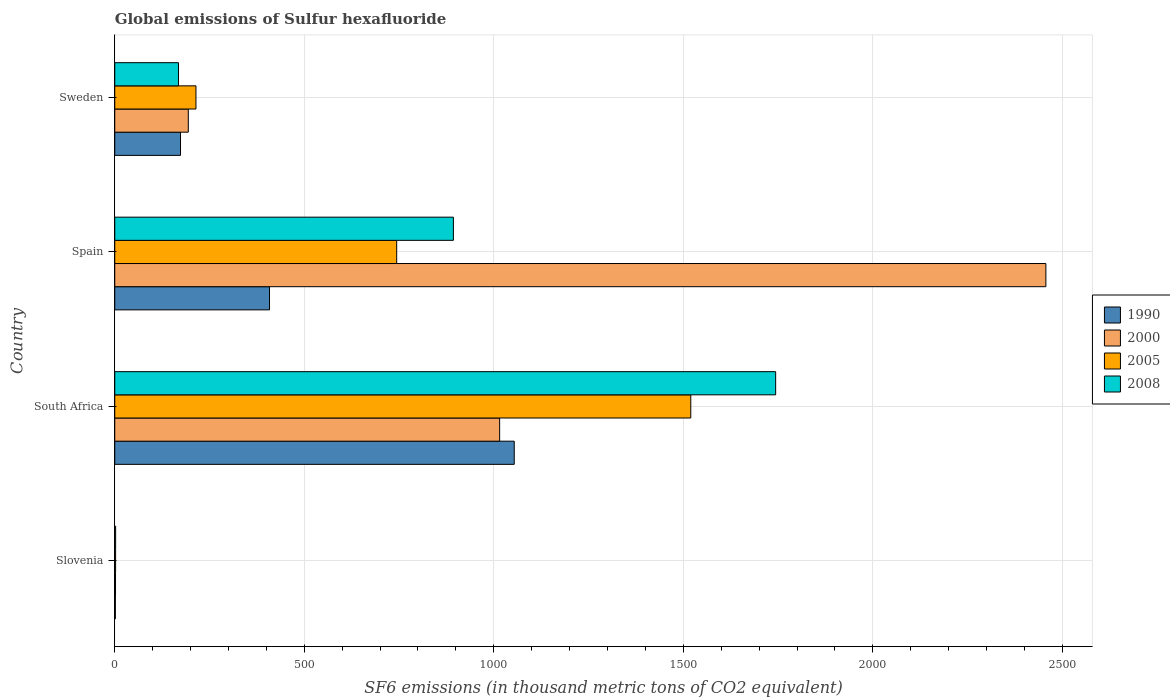How many groups of bars are there?
Offer a very short reply. 4. Are the number of bars per tick equal to the number of legend labels?
Ensure brevity in your answer.  Yes. Are the number of bars on each tick of the Y-axis equal?
Provide a succinct answer. Yes. How many bars are there on the 2nd tick from the top?
Keep it short and to the point. 4. What is the label of the 4th group of bars from the top?
Keep it short and to the point. Slovenia. Across all countries, what is the maximum global emissions of Sulfur hexafluoride in 2008?
Make the answer very short. 1743.6. Across all countries, what is the minimum global emissions of Sulfur hexafluoride in 2005?
Your answer should be compact. 2.2. In which country was the global emissions of Sulfur hexafluoride in 2000 maximum?
Your answer should be compact. Spain. In which country was the global emissions of Sulfur hexafluoride in 2008 minimum?
Provide a short and direct response. Slovenia. What is the total global emissions of Sulfur hexafluoride in 2005 in the graph?
Give a very brief answer. 2479.9. What is the difference between the global emissions of Sulfur hexafluoride in 2008 in South Africa and that in Spain?
Offer a very short reply. 850.2. What is the difference between the global emissions of Sulfur hexafluoride in 1990 in Slovenia and the global emissions of Sulfur hexafluoride in 2000 in Spain?
Your answer should be very brief. -2454.9. What is the average global emissions of Sulfur hexafluoride in 2005 per country?
Keep it short and to the point. 619.97. What is the difference between the global emissions of Sulfur hexafluoride in 2005 and global emissions of Sulfur hexafluoride in 2008 in South Africa?
Provide a short and direct response. -223.9. In how many countries, is the global emissions of Sulfur hexafluoride in 2008 greater than 500 thousand metric tons?
Your response must be concise. 2. What is the ratio of the global emissions of Sulfur hexafluoride in 2005 in South Africa to that in Sweden?
Keep it short and to the point. 7.09. What is the difference between the highest and the second highest global emissions of Sulfur hexafluoride in 2005?
Provide a succinct answer. 775.9. What is the difference between the highest and the lowest global emissions of Sulfur hexafluoride in 1990?
Make the answer very short. 1052.3. In how many countries, is the global emissions of Sulfur hexafluoride in 2000 greater than the average global emissions of Sulfur hexafluoride in 2000 taken over all countries?
Offer a very short reply. 2. Is the sum of the global emissions of Sulfur hexafluoride in 2005 in South Africa and Spain greater than the maximum global emissions of Sulfur hexafluoride in 2008 across all countries?
Keep it short and to the point. Yes. Is it the case that in every country, the sum of the global emissions of Sulfur hexafluoride in 2005 and global emissions of Sulfur hexafluoride in 2008 is greater than the sum of global emissions of Sulfur hexafluoride in 2000 and global emissions of Sulfur hexafluoride in 1990?
Give a very brief answer. No. What does the 1st bar from the top in South Africa represents?
Your answer should be compact. 2008. What does the 3rd bar from the bottom in Slovenia represents?
Provide a short and direct response. 2005. Are all the bars in the graph horizontal?
Provide a short and direct response. Yes. How many countries are there in the graph?
Offer a terse response. 4. Are the values on the major ticks of X-axis written in scientific E-notation?
Offer a very short reply. No. Does the graph contain any zero values?
Your answer should be very brief. No. How many legend labels are there?
Provide a succinct answer. 4. How are the legend labels stacked?
Ensure brevity in your answer.  Vertical. What is the title of the graph?
Offer a terse response. Global emissions of Sulfur hexafluoride. Does "2007" appear as one of the legend labels in the graph?
Your answer should be compact. No. What is the label or title of the X-axis?
Your response must be concise. SF6 emissions (in thousand metric tons of CO2 equivalent). What is the SF6 emissions (in thousand metric tons of CO2 equivalent) in 2008 in Slovenia?
Offer a terse response. 2.3. What is the SF6 emissions (in thousand metric tons of CO2 equivalent) in 1990 in South Africa?
Offer a very short reply. 1053.9. What is the SF6 emissions (in thousand metric tons of CO2 equivalent) of 2000 in South Africa?
Provide a short and direct response. 1015.4. What is the SF6 emissions (in thousand metric tons of CO2 equivalent) in 2005 in South Africa?
Ensure brevity in your answer.  1519.7. What is the SF6 emissions (in thousand metric tons of CO2 equivalent) of 2008 in South Africa?
Your answer should be compact. 1743.6. What is the SF6 emissions (in thousand metric tons of CO2 equivalent) of 1990 in Spain?
Your answer should be very brief. 408.3. What is the SF6 emissions (in thousand metric tons of CO2 equivalent) of 2000 in Spain?
Make the answer very short. 2456.5. What is the SF6 emissions (in thousand metric tons of CO2 equivalent) of 2005 in Spain?
Keep it short and to the point. 743.8. What is the SF6 emissions (in thousand metric tons of CO2 equivalent) of 2008 in Spain?
Provide a short and direct response. 893.4. What is the SF6 emissions (in thousand metric tons of CO2 equivalent) of 1990 in Sweden?
Ensure brevity in your answer.  173.5. What is the SF6 emissions (in thousand metric tons of CO2 equivalent) of 2000 in Sweden?
Give a very brief answer. 194. What is the SF6 emissions (in thousand metric tons of CO2 equivalent) in 2005 in Sweden?
Provide a short and direct response. 214.2. What is the SF6 emissions (in thousand metric tons of CO2 equivalent) of 2008 in Sweden?
Your answer should be compact. 168.1. Across all countries, what is the maximum SF6 emissions (in thousand metric tons of CO2 equivalent) of 1990?
Your answer should be very brief. 1053.9. Across all countries, what is the maximum SF6 emissions (in thousand metric tons of CO2 equivalent) of 2000?
Ensure brevity in your answer.  2456.5. Across all countries, what is the maximum SF6 emissions (in thousand metric tons of CO2 equivalent) of 2005?
Your answer should be very brief. 1519.7. Across all countries, what is the maximum SF6 emissions (in thousand metric tons of CO2 equivalent) in 2008?
Your answer should be compact. 1743.6. Across all countries, what is the minimum SF6 emissions (in thousand metric tons of CO2 equivalent) in 2008?
Keep it short and to the point. 2.3. What is the total SF6 emissions (in thousand metric tons of CO2 equivalent) in 1990 in the graph?
Your response must be concise. 1637.3. What is the total SF6 emissions (in thousand metric tons of CO2 equivalent) in 2000 in the graph?
Give a very brief answer. 3667.9. What is the total SF6 emissions (in thousand metric tons of CO2 equivalent) of 2005 in the graph?
Offer a terse response. 2479.9. What is the total SF6 emissions (in thousand metric tons of CO2 equivalent) of 2008 in the graph?
Keep it short and to the point. 2807.4. What is the difference between the SF6 emissions (in thousand metric tons of CO2 equivalent) in 1990 in Slovenia and that in South Africa?
Your response must be concise. -1052.3. What is the difference between the SF6 emissions (in thousand metric tons of CO2 equivalent) in 2000 in Slovenia and that in South Africa?
Keep it short and to the point. -1013.4. What is the difference between the SF6 emissions (in thousand metric tons of CO2 equivalent) of 2005 in Slovenia and that in South Africa?
Offer a terse response. -1517.5. What is the difference between the SF6 emissions (in thousand metric tons of CO2 equivalent) in 2008 in Slovenia and that in South Africa?
Offer a very short reply. -1741.3. What is the difference between the SF6 emissions (in thousand metric tons of CO2 equivalent) in 1990 in Slovenia and that in Spain?
Your answer should be very brief. -406.7. What is the difference between the SF6 emissions (in thousand metric tons of CO2 equivalent) in 2000 in Slovenia and that in Spain?
Provide a short and direct response. -2454.5. What is the difference between the SF6 emissions (in thousand metric tons of CO2 equivalent) in 2005 in Slovenia and that in Spain?
Offer a terse response. -741.6. What is the difference between the SF6 emissions (in thousand metric tons of CO2 equivalent) of 2008 in Slovenia and that in Spain?
Offer a terse response. -891.1. What is the difference between the SF6 emissions (in thousand metric tons of CO2 equivalent) of 1990 in Slovenia and that in Sweden?
Your answer should be compact. -171.9. What is the difference between the SF6 emissions (in thousand metric tons of CO2 equivalent) in 2000 in Slovenia and that in Sweden?
Make the answer very short. -192. What is the difference between the SF6 emissions (in thousand metric tons of CO2 equivalent) of 2005 in Slovenia and that in Sweden?
Ensure brevity in your answer.  -212. What is the difference between the SF6 emissions (in thousand metric tons of CO2 equivalent) of 2008 in Slovenia and that in Sweden?
Offer a very short reply. -165.8. What is the difference between the SF6 emissions (in thousand metric tons of CO2 equivalent) of 1990 in South Africa and that in Spain?
Your answer should be compact. 645.6. What is the difference between the SF6 emissions (in thousand metric tons of CO2 equivalent) of 2000 in South Africa and that in Spain?
Provide a succinct answer. -1441.1. What is the difference between the SF6 emissions (in thousand metric tons of CO2 equivalent) in 2005 in South Africa and that in Spain?
Your answer should be very brief. 775.9. What is the difference between the SF6 emissions (in thousand metric tons of CO2 equivalent) in 2008 in South Africa and that in Spain?
Offer a terse response. 850.2. What is the difference between the SF6 emissions (in thousand metric tons of CO2 equivalent) of 1990 in South Africa and that in Sweden?
Your answer should be very brief. 880.4. What is the difference between the SF6 emissions (in thousand metric tons of CO2 equivalent) of 2000 in South Africa and that in Sweden?
Offer a terse response. 821.4. What is the difference between the SF6 emissions (in thousand metric tons of CO2 equivalent) in 2005 in South Africa and that in Sweden?
Offer a terse response. 1305.5. What is the difference between the SF6 emissions (in thousand metric tons of CO2 equivalent) in 2008 in South Africa and that in Sweden?
Keep it short and to the point. 1575.5. What is the difference between the SF6 emissions (in thousand metric tons of CO2 equivalent) of 1990 in Spain and that in Sweden?
Offer a terse response. 234.8. What is the difference between the SF6 emissions (in thousand metric tons of CO2 equivalent) in 2000 in Spain and that in Sweden?
Provide a short and direct response. 2262.5. What is the difference between the SF6 emissions (in thousand metric tons of CO2 equivalent) of 2005 in Spain and that in Sweden?
Provide a short and direct response. 529.6. What is the difference between the SF6 emissions (in thousand metric tons of CO2 equivalent) of 2008 in Spain and that in Sweden?
Offer a very short reply. 725.3. What is the difference between the SF6 emissions (in thousand metric tons of CO2 equivalent) in 1990 in Slovenia and the SF6 emissions (in thousand metric tons of CO2 equivalent) in 2000 in South Africa?
Offer a terse response. -1013.8. What is the difference between the SF6 emissions (in thousand metric tons of CO2 equivalent) of 1990 in Slovenia and the SF6 emissions (in thousand metric tons of CO2 equivalent) of 2005 in South Africa?
Make the answer very short. -1518.1. What is the difference between the SF6 emissions (in thousand metric tons of CO2 equivalent) in 1990 in Slovenia and the SF6 emissions (in thousand metric tons of CO2 equivalent) in 2008 in South Africa?
Your answer should be compact. -1742. What is the difference between the SF6 emissions (in thousand metric tons of CO2 equivalent) of 2000 in Slovenia and the SF6 emissions (in thousand metric tons of CO2 equivalent) of 2005 in South Africa?
Offer a terse response. -1517.7. What is the difference between the SF6 emissions (in thousand metric tons of CO2 equivalent) of 2000 in Slovenia and the SF6 emissions (in thousand metric tons of CO2 equivalent) of 2008 in South Africa?
Provide a short and direct response. -1741.6. What is the difference between the SF6 emissions (in thousand metric tons of CO2 equivalent) in 2005 in Slovenia and the SF6 emissions (in thousand metric tons of CO2 equivalent) in 2008 in South Africa?
Your answer should be compact. -1741.4. What is the difference between the SF6 emissions (in thousand metric tons of CO2 equivalent) in 1990 in Slovenia and the SF6 emissions (in thousand metric tons of CO2 equivalent) in 2000 in Spain?
Offer a terse response. -2454.9. What is the difference between the SF6 emissions (in thousand metric tons of CO2 equivalent) in 1990 in Slovenia and the SF6 emissions (in thousand metric tons of CO2 equivalent) in 2005 in Spain?
Offer a terse response. -742.2. What is the difference between the SF6 emissions (in thousand metric tons of CO2 equivalent) in 1990 in Slovenia and the SF6 emissions (in thousand metric tons of CO2 equivalent) in 2008 in Spain?
Make the answer very short. -891.8. What is the difference between the SF6 emissions (in thousand metric tons of CO2 equivalent) of 2000 in Slovenia and the SF6 emissions (in thousand metric tons of CO2 equivalent) of 2005 in Spain?
Offer a terse response. -741.8. What is the difference between the SF6 emissions (in thousand metric tons of CO2 equivalent) in 2000 in Slovenia and the SF6 emissions (in thousand metric tons of CO2 equivalent) in 2008 in Spain?
Your answer should be compact. -891.4. What is the difference between the SF6 emissions (in thousand metric tons of CO2 equivalent) of 2005 in Slovenia and the SF6 emissions (in thousand metric tons of CO2 equivalent) of 2008 in Spain?
Your answer should be compact. -891.2. What is the difference between the SF6 emissions (in thousand metric tons of CO2 equivalent) in 1990 in Slovenia and the SF6 emissions (in thousand metric tons of CO2 equivalent) in 2000 in Sweden?
Your answer should be very brief. -192.4. What is the difference between the SF6 emissions (in thousand metric tons of CO2 equivalent) of 1990 in Slovenia and the SF6 emissions (in thousand metric tons of CO2 equivalent) of 2005 in Sweden?
Give a very brief answer. -212.6. What is the difference between the SF6 emissions (in thousand metric tons of CO2 equivalent) in 1990 in Slovenia and the SF6 emissions (in thousand metric tons of CO2 equivalent) in 2008 in Sweden?
Provide a succinct answer. -166.5. What is the difference between the SF6 emissions (in thousand metric tons of CO2 equivalent) of 2000 in Slovenia and the SF6 emissions (in thousand metric tons of CO2 equivalent) of 2005 in Sweden?
Your answer should be very brief. -212.2. What is the difference between the SF6 emissions (in thousand metric tons of CO2 equivalent) of 2000 in Slovenia and the SF6 emissions (in thousand metric tons of CO2 equivalent) of 2008 in Sweden?
Keep it short and to the point. -166.1. What is the difference between the SF6 emissions (in thousand metric tons of CO2 equivalent) in 2005 in Slovenia and the SF6 emissions (in thousand metric tons of CO2 equivalent) in 2008 in Sweden?
Your answer should be very brief. -165.9. What is the difference between the SF6 emissions (in thousand metric tons of CO2 equivalent) of 1990 in South Africa and the SF6 emissions (in thousand metric tons of CO2 equivalent) of 2000 in Spain?
Provide a succinct answer. -1402.6. What is the difference between the SF6 emissions (in thousand metric tons of CO2 equivalent) in 1990 in South Africa and the SF6 emissions (in thousand metric tons of CO2 equivalent) in 2005 in Spain?
Provide a succinct answer. 310.1. What is the difference between the SF6 emissions (in thousand metric tons of CO2 equivalent) in 1990 in South Africa and the SF6 emissions (in thousand metric tons of CO2 equivalent) in 2008 in Spain?
Provide a succinct answer. 160.5. What is the difference between the SF6 emissions (in thousand metric tons of CO2 equivalent) of 2000 in South Africa and the SF6 emissions (in thousand metric tons of CO2 equivalent) of 2005 in Spain?
Give a very brief answer. 271.6. What is the difference between the SF6 emissions (in thousand metric tons of CO2 equivalent) in 2000 in South Africa and the SF6 emissions (in thousand metric tons of CO2 equivalent) in 2008 in Spain?
Keep it short and to the point. 122. What is the difference between the SF6 emissions (in thousand metric tons of CO2 equivalent) in 2005 in South Africa and the SF6 emissions (in thousand metric tons of CO2 equivalent) in 2008 in Spain?
Provide a short and direct response. 626.3. What is the difference between the SF6 emissions (in thousand metric tons of CO2 equivalent) of 1990 in South Africa and the SF6 emissions (in thousand metric tons of CO2 equivalent) of 2000 in Sweden?
Keep it short and to the point. 859.9. What is the difference between the SF6 emissions (in thousand metric tons of CO2 equivalent) in 1990 in South Africa and the SF6 emissions (in thousand metric tons of CO2 equivalent) in 2005 in Sweden?
Give a very brief answer. 839.7. What is the difference between the SF6 emissions (in thousand metric tons of CO2 equivalent) of 1990 in South Africa and the SF6 emissions (in thousand metric tons of CO2 equivalent) of 2008 in Sweden?
Make the answer very short. 885.8. What is the difference between the SF6 emissions (in thousand metric tons of CO2 equivalent) in 2000 in South Africa and the SF6 emissions (in thousand metric tons of CO2 equivalent) in 2005 in Sweden?
Provide a short and direct response. 801.2. What is the difference between the SF6 emissions (in thousand metric tons of CO2 equivalent) of 2000 in South Africa and the SF6 emissions (in thousand metric tons of CO2 equivalent) of 2008 in Sweden?
Offer a very short reply. 847.3. What is the difference between the SF6 emissions (in thousand metric tons of CO2 equivalent) in 2005 in South Africa and the SF6 emissions (in thousand metric tons of CO2 equivalent) in 2008 in Sweden?
Your response must be concise. 1351.6. What is the difference between the SF6 emissions (in thousand metric tons of CO2 equivalent) in 1990 in Spain and the SF6 emissions (in thousand metric tons of CO2 equivalent) in 2000 in Sweden?
Provide a succinct answer. 214.3. What is the difference between the SF6 emissions (in thousand metric tons of CO2 equivalent) of 1990 in Spain and the SF6 emissions (in thousand metric tons of CO2 equivalent) of 2005 in Sweden?
Provide a short and direct response. 194.1. What is the difference between the SF6 emissions (in thousand metric tons of CO2 equivalent) in 1990 in Spain and the SF6 emissions (in thousand metric tons of CO2 equivalent) in 2008 in Sweden?
Provide a succinct answer. 240.2. What is the difference between the SF6 emissions (in thousand metric tons of CO2 equivalent) in 2000 in Spain and the SF6 emissions (in thousand metric tons of CO2 equivalent) in 2005 in Sweden?
Your response must be concise. 2242.3. What is the difference between the SF6 emissions (in thousand metric tons of CO2 equivalent) in 2000 in Spain and the SF6 emissions (in thousand metric tons of CO2 equivalent) in 2008 in Sweden?
Your response must be concise. 2288.4. What is the difference between the SF6 emissions (in thousand metric tons of CO2 equivalent) in 2005 in Spain and the SF6 emissions (in thousand metric tons of CO2 equivalent) in 2008 in Sweden?
Provide a short and direct response. 575.7. What is the average SF6 emissions (in thousand metric tons of CO2 equivalent) of 1990 per country?
Ensure brevity in your answer.  409.32. What is the average SF6 emissions (in thousand metric tons of CO2 equivalent) in 2000 per country?
Your answer should be very brief. 916.98. What is the average SF6 emissions (in thousand metric tons of CO2 equivalent) of 2005 per country?
Give a very brief answer. 619.98. What is the average SF6 emissions (in thousand metric tons of CO2 equivalent) in 2008 per country?
Your response must be concise. 701.85. What is the difference between the SF6 emissions (in thousand metric tons of CO2 equivalent) of 1990 and SF6 emissions (in thousand metric tons of CO2 equivalent) of 2000 in Slovenia?
Provide a short and direct response. -0.4. What is the difference between the SF6 emissions (in thousand metric tons of CO2 equivalent) of 1990 and SF6 emissions (in thousand metric tons of CO2 equivalent) of 2005 in Slovenia?
Your answer should be compact. -0.6. What is the difference between the SF6 emissions (in thousand metric tons of CO2 equivalent) of 2000 and SF6 emissions (in thousand metric tons of CO2 equivalent) of 2008 in Slovenia?
Ensure brevity in your answer.  -0.3. What is the difference between the SF6 emissions (in thousand metric tons of CO2 equivalent) of 1990 and SF6 emissions (in thousand metric tons of CO2 equivalent) of 2000 in South Africa?
Provide a short and direct response. 38.5. What is the difference between the SF6 emissions (in thousand metric tons of CO2 equivalent) in 1990 and SF6 emissions (in thousand metric tons of CO2 equivalent) in 2005 in South Africa?
Your answer should be compact. -465.8. What is the difference between the SF6 emissions (in thousand metric tons of CO2 equivalent) of 1990 and SF6 emissions (in thousand metric tons of CO2 equivalent) of 2008 in South Africa?
Your answer should be compact. -689.7. What is the difference between the SF6 emissions (in thousand metric tons of CO2 equivalent) in 2000 and SF6 emissions (in thousand metric tons of CO2 equivalent) in 2005 in South Africa?
Offer a terse response. -504.3. What is the difference between the SF6 emissions (in thousand metric tons of CO2 equivalent) of 2000 and SF6 emissions (in thousand metric tons of CO2 equivalent) of 2008 in South Africa?
Keep it short and to the point. -728.2. What is the difference between the SF6 emissions (in thousand metric tons of CO2 equivalent) in 2005 and SF6 emissions (in thousand metric tons of CO2 equivalent) in 2008 in South Africa?
Provide a short and direct response. -223.9. What is the difference between the SF6 emissions (in thousand metric tons of CO2 equivalent) of 1990 and SF6 emissions (in thousand metric tons of CO2 equivalent) of 2000 in Spain?
Give a very brief answer. -2048.2. What is the difference between the SF6 emissions (in thousand metric tons of CO2 equivalent) in 1990 and SF6 emissions (in thousand metric tons of CO2 equivalent) in 2005 in Spain?
Offer a very short reply. -335.5. What is the difference between the SF6 emissions (in thousand metric tons of CO2 equivalent) in 1990 and SF6 emissions (in thousand metric tons of CO2 equivalent) in 2008 in Spain?
Keep it short and to the point. -485.1. What is the difference between the SF6 emissions (in thousand metric tons of CO2 equivalent) in 2000 and SF6 emissions (in thousand metric tons of CO2 equivalent) in 2005 in Spain?
Offer a terse response. 1712.7. What is the difference between the SF6 emissions (in thousand metric tons of CO2 equivalent) in 2000 and SF6 emissions (in thousand metric tons of CO2 equivalent) in 2008 in Spain?
Make the answer very short. 1563.1. What is the difference between the SF6 emissions (in thousand metric tons of CO2 equivalent) of 2005 and SF6 emissions (in thousand metric tons of CO2 equivalent) of 2008 in Spain?
Offer a terse response. -149.6. What is the difference between the SF6 emissions (in thousand metric tons of CO2 equivalent) of 1990 and SF6 emissions (in thousand metric tons of CO2 equivalent) of 2000 in Sweden?
Provide a succinct answer. -20.5. What is the difference between the SF6 emissions (in thousand metric tons of CO2 equivalent) of 1990 and SF6 emissions (in thousand metric tons of CO2 equivalent) of 2005 in Sweden?
Offer a terse response. -40.7. What is the difference between the SF6 emissions (in thousand metric tons of CO2 equivalent) of 2000 and SF6 emissions (in thousand metric tons of CO2 equivalent) of 2005 in Sweden?
Keep it short and to the point. -20.2. What is the difference between the SF6 emissions (in thousand metric tons of CO2 equivalent) in 2000 and SF6 emissions (in thousand metric tons of CO2 equivalent) in 2008 in Sweden?
Your response must be concise. 25.9. What is the difference between the SF6 emissions (in thousand metric tons of CO2 equivalent) in 2005 and SF6 emissions (in thousand metric tons of CO2 equivalent) in 2008 in Sweden?
Your response must be concise. 46.1. What is the ratio of the SF6 emissions (in thousand metric tons of CO2 equivalent) of 1990 in Slovenia to that in South Africa?
Offer a terse response. 0. What is the ratio of the SF6 emissions (in thousand metric tons of CO2 equivalent) of 2000 in Slovenia to that in South Africa?
Provide a succinct answer. 0. What is the ratio of the SF6 emissions (in thousand metric tons of CO2 equivalent) of 2005 in Slovenia to that in South Africa?
Ensure brevity in your answer.  0. What is the ratio of the SF6 emissions (in thousand metric tons of CO2 equivalent) in 2008 in Slovenia to that in South Africa?
Provide a short and direct response. 0. What is the ratio of the SF6 emissions (in thousand metric tons of CO2 equivalent) of 1990 in Slovenia to that in Spain?
Your response must be concise. 0. What is the ratio of the SF6 emissions (in thousand metric tons of CO2 equivalent) in 2000 in Slovenia to that in Spain?
Keep it short and to the point. 0. What is the ratio of the SF6 emissions (in thousand metric tons of CO2 equivalent) in 2005 in Slovenia to that in Spain?
Offer a terse response. 0. What is the ratio of the SF6 emissions (in thousand metric tons of CO2 equivalent) in 2008 in Slovenia to that in Spain?
Offer a very short reply. 0. What is the ratio of the SF6 emissions (in thousand metric tons of CO2 equivalent) of 1990 in Slovenia to that in Sweden?
Keep it short and to the point. 0.01. What is the ratio of the SF6 emissions (in thousand metric tons of CO2 equivalent) of 2000 in Slovenia to that in Sweden?
Your response must be concise. 0.01. What is the ratio of the SF6 emissions (in thousand metric tons of CO2 equivalent) in 2005 in Slovenia to that in Sweden?
Your response must be concise. 0.01. What is the ratio of the SF6 emissions (in thousand metric tons of CO2 equivalent) in 2008 in Slovenia to that in Sweden?
Make the answer very short. 0.01. What is the ratio of the SF6 emissions (in thousand metric tons of CO2 equivalent) in 1990 in South Africa to that in Spain?
Keep it short and to the point. 2.58. What is the ratio of the SF6 emissions (in thousand metric tons of CO2 equivalent) of 2000 in South Africa to that in Spain?
Give a very brief answer. 0.41. What is the ratio of the SF6 emissions (in thousand metric tons of CO2 equivalent) of 2005 in South Africa to that in Spain?
Your response must be concise. 2.04. What is the ratio of the SF6 emissions (in thousand metric tons of CO2 equivalent) in 2008 in South Africa to that in Spain?
Provide a short and direct response. 1.95. What is the ratio of the SF6 emissions (in thousand metric tons of CO2 equivalent) of 1990 in South Africa to that in Sweden?
Offer a very short reply. 6.07. What is the ratio of the SF6 emissions (in thousand metric tons of CO2 equivalent) in 2000 in South Africa to that in Sweden?
Ensure brevity in your answer.  5.23. What is the ratio of the SF6 emissions (in thousand metric tons of CO2 equivalent) of 2005 in South Africa to that in Sweden?
Your response must be concise. 7.09. What is the ratio of the SF6 emissions (in thousand metric tons of CO2 equivalent) of 2008 in South Africa to that in Sweden?
Your answer should be compact. 10.37. What is the ratio of the SF6 emissions (in thousand metric tons of CO2 equivalent) in 1990 in Spain to that in Sweden?
Offer a terse response. 2.35. What is the ratio of the SF6 emissions (in thousand metric tons of CO2 equivalent) in 2000 in Spain to that in Sweden?
Keep it short and to the point. 12.66. What is the ratio of the SF6 emissions (in thousand metric tons of CO2 equivalent) of 2005 in Spain to that in Sweden?
Your answer should be compact. 3.47. What is the ratio of the SF6 emissions (in thousand metric tons of CO2 equivalent) in 2008 in Spain to that in Sweden?
Offer a very short reply. 5.31. What is the difference between the highest and the second highest SF6 emissions (in thousand metric tons of CO2 equivalent) of 1990?
Your answer should be compact. 645.6. What is the difference between the highest and the second highest SF6 emissions (in thousand metric tons of CO2 equivalent) in 2000?
Ensure brevity in your answer.  1441.1. What is the difference between the highest and the second highest SF6 emissions (in thousand metric tons of CO2 equivalent) of 2005?
Give a very brief answer. 775.9. What is the difference between the highest and the second highest SF6 emissions (in thousand metric tons of CO2 equivalent) in 2008?
Your answer should be compact. 850.2. What is the difference between the highest and the lowest SF6 emissions (in thousand metric tons of CO2 equivalent) in 1990?
Your answer should be very brief. 1052.3. What is the difference between the highest and the lowest SF6 emissions (in thousand metric tons of CO2 equivalent) in 2000?
Your answer should be very brief. 2454.5. What is the difference between the highest and the lowest SF6 emissions (in thousand metric tons of CO2 equivalent) in 2005?
Make the answer very short. 1517.5. What is the difference between the highest and the lowest SF6 emissions (in thousand metric tons of CO2 equivalent) in 2008?
Keep it short and to the point. 1741.3. 